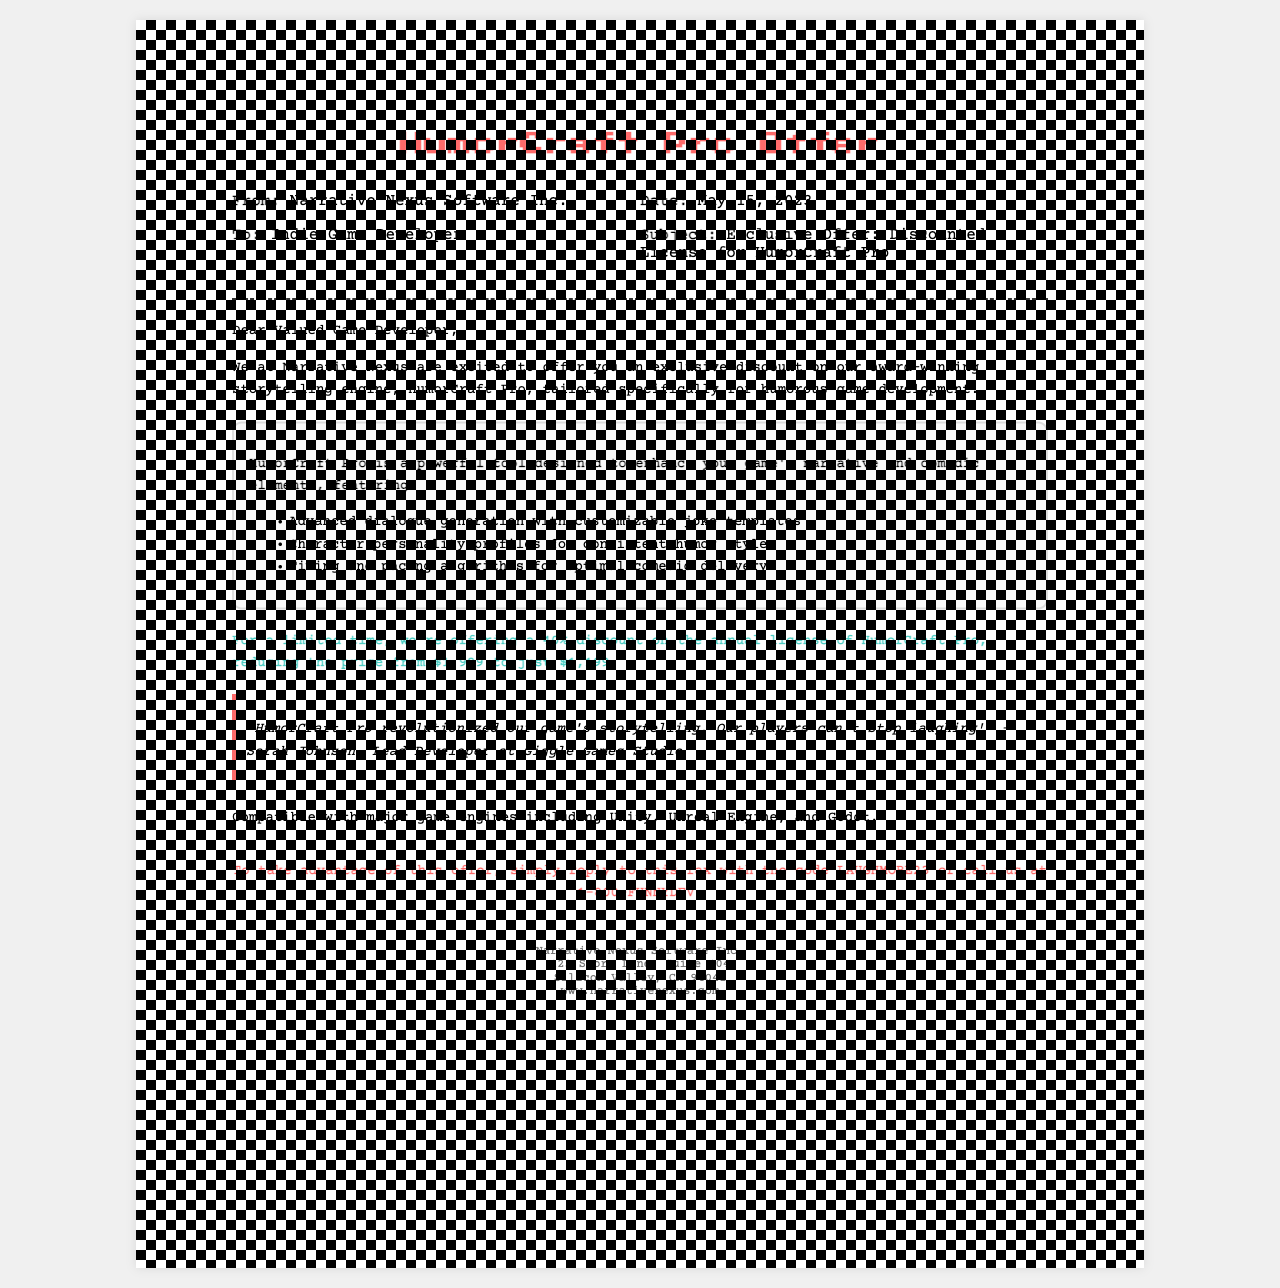What is the name of the software company? The software company that sent the fax is named Narrative Nexus Software Inc.
Answer: Narrative Nexus Software Inc What is the discount percentage offered on HumorCraft Pro? The document states that there is a 40% discount on HumorCraft Pro.
Answer: 40% What is the regular price of HumorCraft Pro? The original price before discount for HumorCraft Pro is $1,999.
Answer: $1,999 What is the discounted price of HumorCraft Pro? After applying the discount, the price of HumorCraft Pro is reduced to $1,199.
Answer: $1,199 What is the date mentioned in the fax? The fax specifies the date as May 15, 2023.
Answer: May 15, 2023 What should you do to take advantage of the offer? To take advantage of the offer, you should reply with the code LAUGHMORE23 or call the provided phone number.
Answer: Reply with code LAUGHMORE23 or call 1-800-FUNNYDEV Who is the testimonial from? The testimonial is from Sarah Johnson, who is the Lead Developer at Giggle Games Studio.
Answer: Sarah Johnson Which game engines is HumorCraft Pro compatible with? The document mentions compatibility with Unity, Unreal Engine, and Godot.
Answer: Unity, Unreal Engine, Godot What type of document is this? This document is a fax.
Answer: Fax 